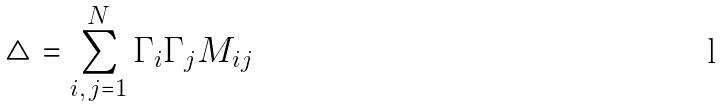Convert formula to latex. <formula><loc_0><loc_0><loc_500><loc_500>\triangle = \sum _ { i , \, j = 1 } ^ { N } \Gamma _ { i } \Gamma _ { j } M _ { i j }</formula> 